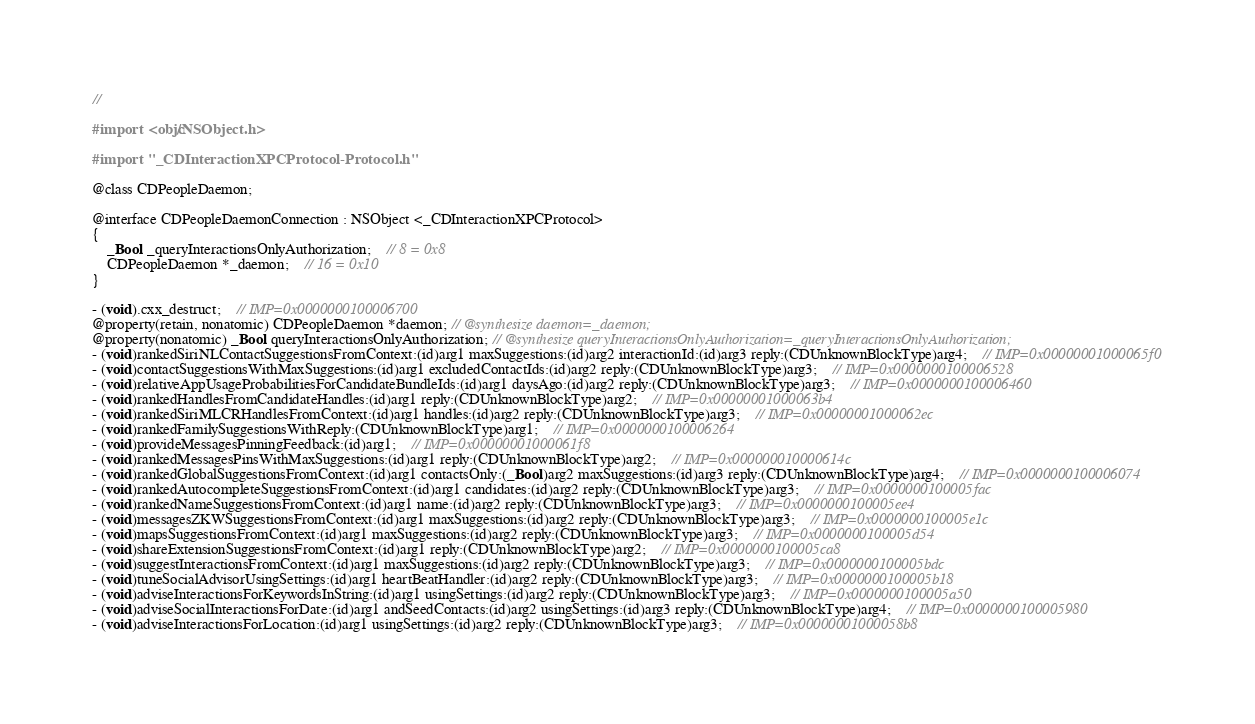Convert code to text. <code><loc_0><loc_0><loc_500><loc_500><_C_>//

#import <objc/NSObject.h>

#import "_CDInteractionXPCProtocol-Protocol.h"

@class CDPeopleDaemon;

@interface CDPeopleDaemonConnection : NSObject <_CDInteractionXPCProtocol>
{
    _Bool _queryInteractionsOnlyAuthorization;	// 8 = 0x8
    CDPeopleDaemon *_daemon;	// 16 = 0x10
}

- (void).cxx_destruct;	// IMP=0x0000000100006700
@property(retain, nonatomic) CDPeopleDaemon *daemon; // @synthesize daemon=_daemon;
@property(nonatomic) _Bool queryInteractionsOnlyAuthorization; // @synthesize queryInteractionsOnlyAuthorization=_queryInteractionsOnlyAuthorization;
- (void)rankedSiriNLContactSuggestionsFromContext:(id)arg1 maxSuggestions:(id)arg2 interactionId:(id)arg3 reply:(CDUnknownBlockType)arg4;	// IMP=0x00000001000065f0
- (void)contactSuggestionsWithMaxSuggestions:(id)arg1 excludedContactIds:(id)arg2 reply:(CDUnknownBlockType)arg3;	// IMP=0x0000000100006528
- (void)relativeAppUsageProbabilitiesForCandidateBundleIds:(id)arg1 daysAgo:(id)arg2 reply:(CDUnknownBlockType)arg3;	// IMP=0x0000000100006460
- (void)rankedHandlesFromCandidateHandles:(id)arg1 reply:(CDUnknownBlockType)arg2;	// IMP=0x00000001000063b4
- (void)rankedSiriMLCRHandlesFromContext:(id)arg1 handles:(id)arg2 reply:(CDUnknownBlockType)arg3;	// IMP=0x00000001000062ec
- (void)rankedFamilySuggestionsWithReply:(CDUnknownBlockType)arg1;	// IMP=0x0000000100006264
- (void)provideMessagesPinningFeedback:(id)arg1;	// IMP=0x00000001000061f8
- (void)rankedMessagesPinsWithMaxSuggestions:(id)arg1 reply:(CDUnknownBlockType)arg2;	// IMP=0x000000010000614c
- (void)rankedGlobalSuggestionsFromContext:(id)arg1 contactsOnly:(_Bool)arg2 maxSuggestions:(id)arg3 reply:(CDUnknownBlockType)arg4;	// IMP=0x0000000100006074
- (void)rankedAutocompleteSuggestionsFromContext:(id)arg1 candidates:(id)arg2 reply:(CDUnknownBlockType)arg3;	// IMP=0x0000000100005fac
- (void)rankedNameSuggestionsFromContext:(id)arg1 name:(id)arg2 reply:(CDUnknownBlockType)arg3;	// IMP=0x0000000100005ee4
- (void)messagesZKWSuggestionsFromContext:(id)arg1 maxSuggestions:(id)arg2 reply:(CDUnknownBlockType)arg3;	// IMP=0x0000000100005e1c
- (void)mapsSuggestionsFromContext:(id)arg1 maxSuggestions:(id)arg2 reply:(CDUnknownBlockType)arg3;	// IMP=0x0000000100005d54
- (void)shareExtensionSuggestionsFromContext:(id)arg1 reply:(CDUnknownBlockType)arg2;	// IMP=0x0000000100005ca8
- (void)suggestInteractionsFromContext:(id)arg1 maxSuggestions:(id)arg2 reply:(CDUnknownBlockType)arg3;	// IMP=0x0000000100005bdc
- (void)tuneSocialAdvisorUsingSettings:(id)arg1 heartBeatHandler:(id)arg2 reply:(CDUnknownBlockType)arg3;	// IMP=0x0000000100005b18
- (void)adviseInteractionsForKeywordsInString:(id)arg1 usingSettings:(id)arg2 reply:(CDUnknownBlockType)arg3;	// IMP=0x0000000100005a50
- (void)adviseSocialInteractionsForDate:(id)arg1 andSeedContacts:(id)arg2 usingSettings:(id)arg3 reply:(CDUnknownBlockType)arg4;	// IMP=0x0000000100005980
- (void)adviseInteractionsForLocation:(id)arg1 usingSettings:(id)arg2 reply:(CDUnknownBlockType)arg3;	// IMP=0x00000001000058b8</code> 